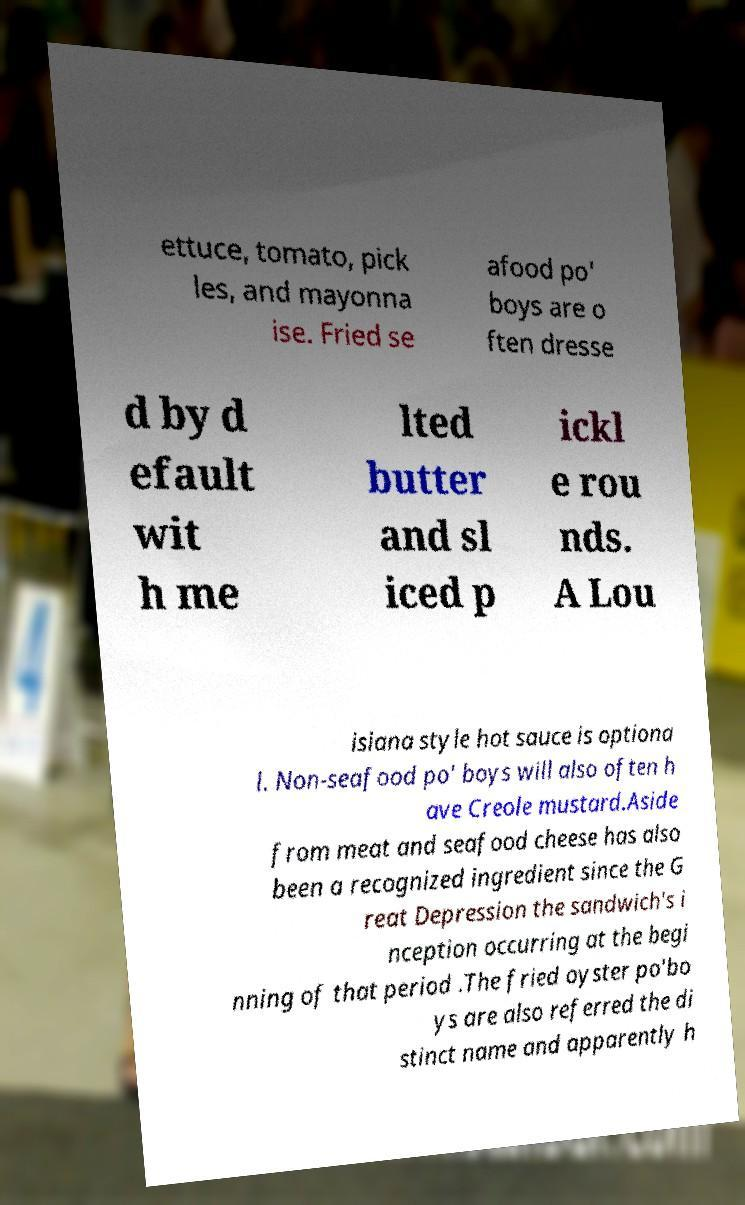For documentation purposes, I need the text within this image transcribed. Could you provide that? ettuce, tomato, pick les, and mayonna ise. Fried se afood po' boys are o ften dresse d by d efault wit h me lted butter and sl iced p ickl e rou nds. A Lou isiana style hot sauce is optiona l. Non-seafood po' boys will also often h ave Creole mustard.Aside from meat and seafood cheese has also been a recognized ingredient since the G reat Depression the sandwich's i nception occurring at the begi nning of that period .The fried oyster po'bo ys are also referred the di stinct name and apparently h 